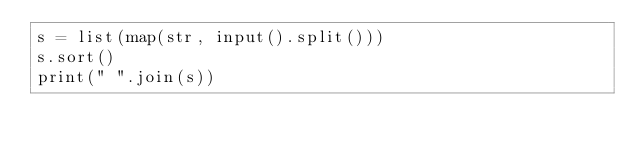<code> <loc_0><loc_0><loc_500><loc_500><_Python_>s = list(map(str, input().split()))
s.sort()
print(" ".join(s))

</code> 